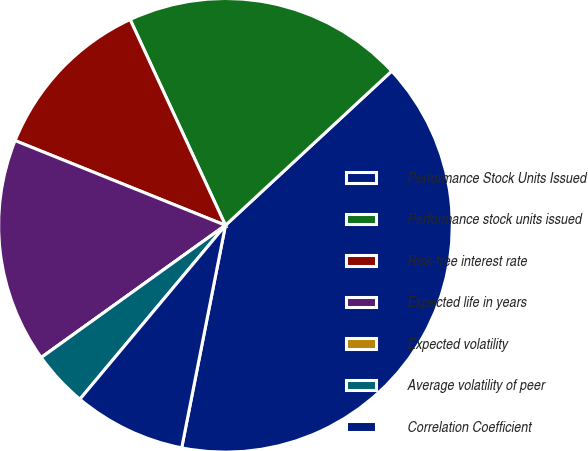Convert chart. <chart><loc_0><loc_0><loc_500><loc_500><pie_chart><fcel>Performance Stock Units Issued<fcel>Performance stock units issued<fcel>Risk-free interest rate<fcel>Expected life in years<fcel>Expected volatility<fcel>Average volatility of peer<fcel>Correlation Coefficient<nl><fcel>39.99%<fcel>20.0%<fcel>12.0%<fcel>16.0%<fcel>0.0%<fcel>4.0%<fcel>8.0%<nl></chart> 